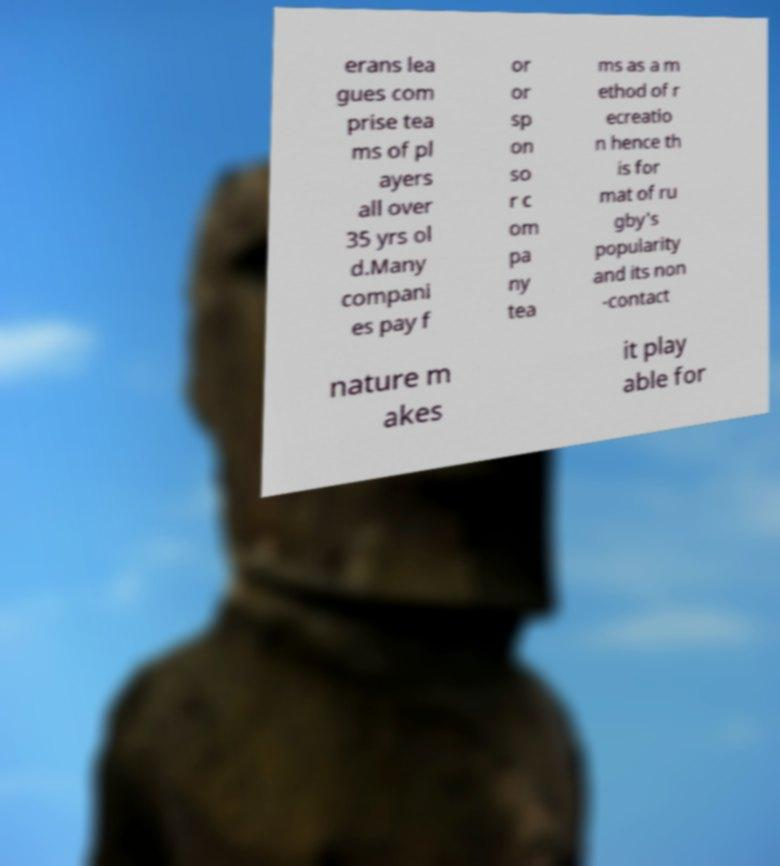There's text embedded in this image that I need extracted. Can you transcribe it verbatim? erans lea gues com prise tea ms of pl ayers all over 35 yrs ol d.Many compani es pay f or or sp on so r c om pa ny tea ms as a m ethod of r ecreatio n hence th is for mat of ru gby's popularity and its non -contact nature m akes it play able for 